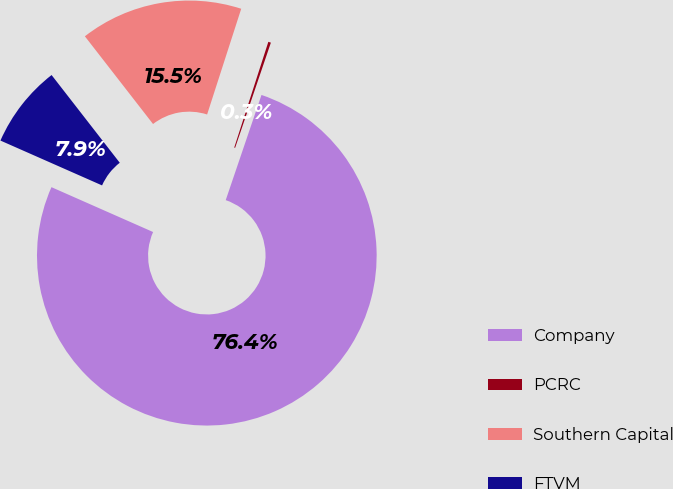Convert chart. <chart><loc_0><loc_0><loc_500><loc_500><pie_chart><fcel>Company<fcel>PCRC<fcel>Southern Capital<fcel>FTVM<nl><fcel>76.39%<fcel>0.25%<fcel>15.48%<fcel>7.87%<nl></chart> 